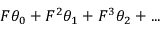<formula> <loc_0><loc_0><loc_500><loc_500>F \theta _ { 0 } + F ^ { 2 } \theta _ { 1 } + F ^ { 3 } \theta _ { 2 } + \dots</formula> 